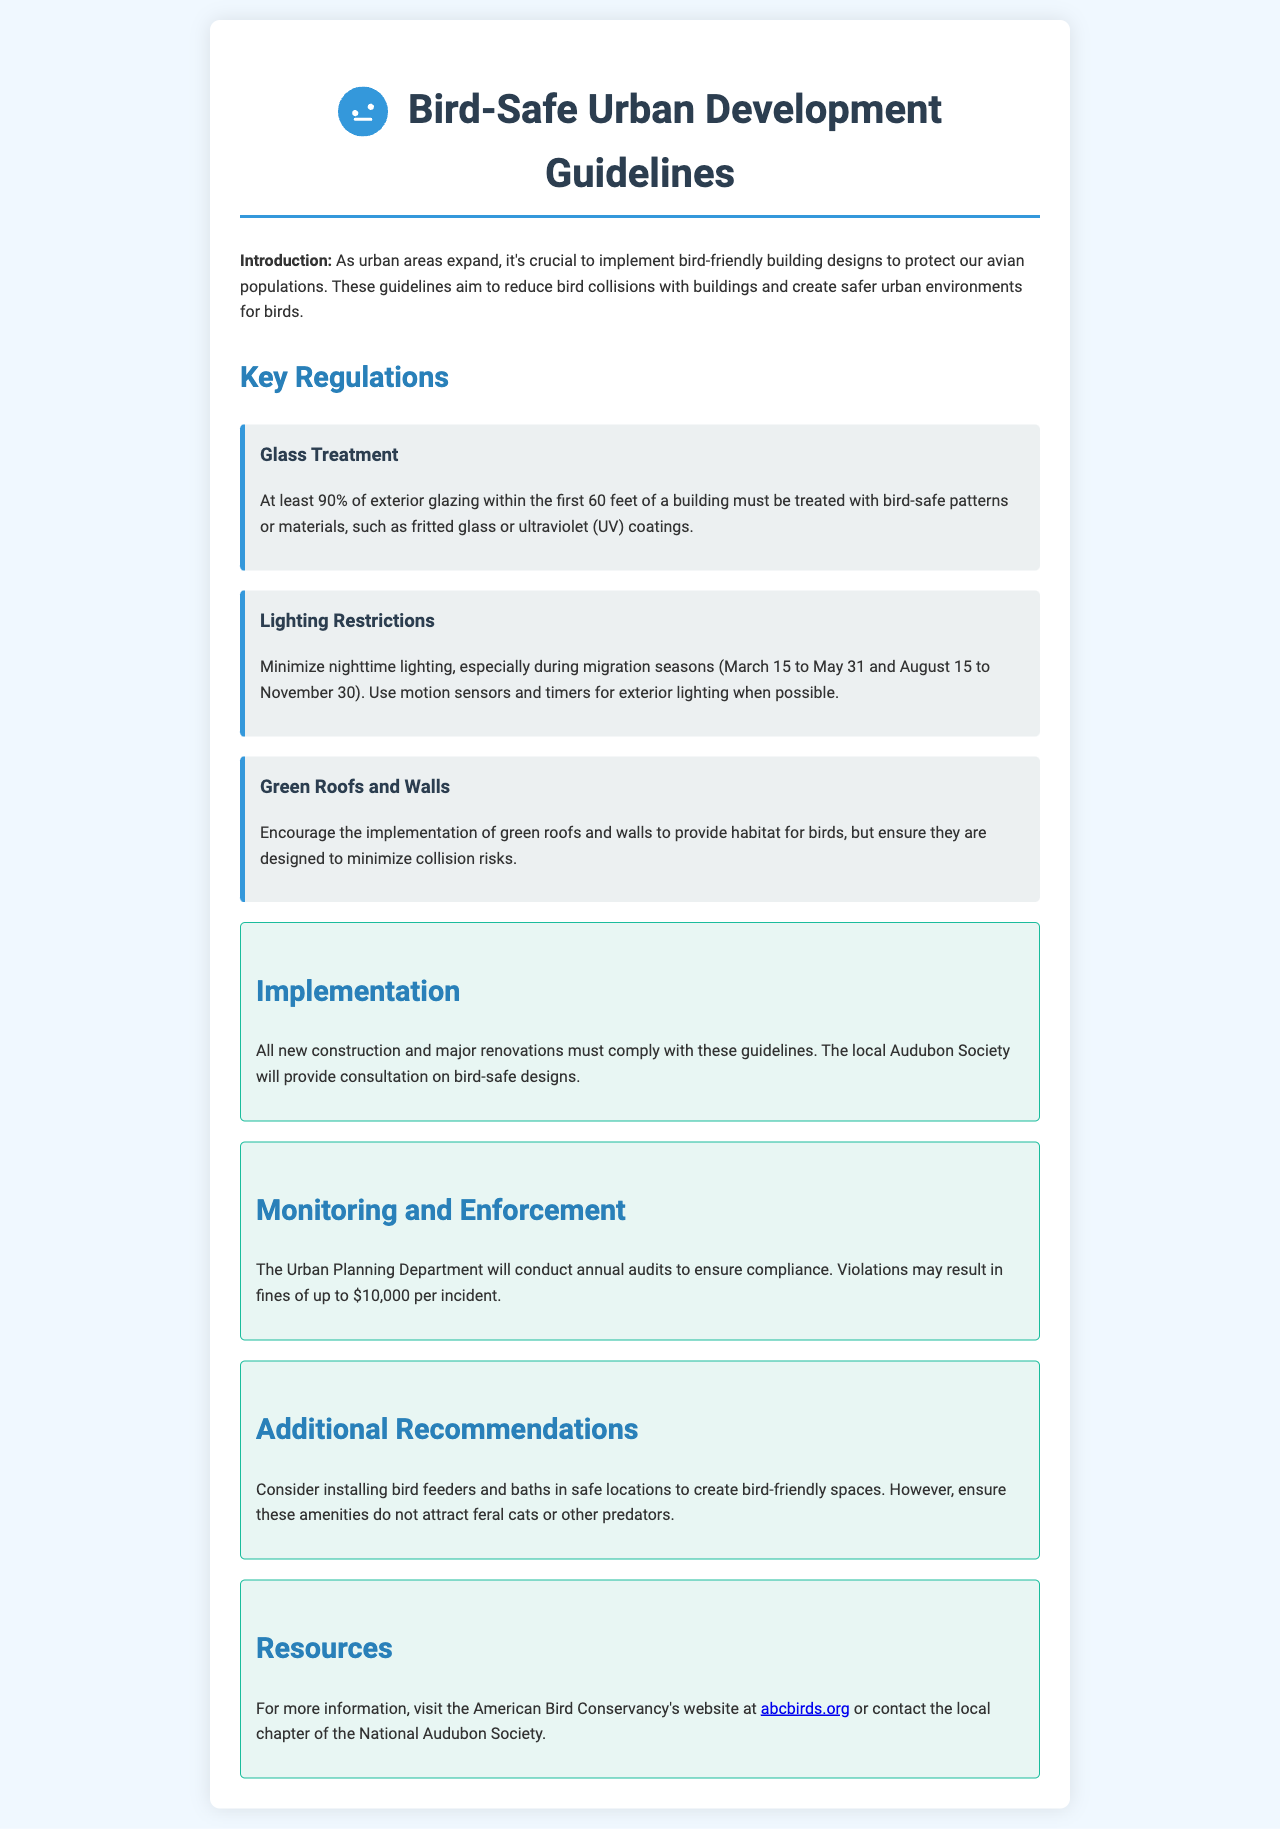what percentage of exterior glazing must be bird-safe treated? The document states that at least 90% of exterior glazing within the first 60 feet must be treated with bird-safe patterns or materials.
Answer: 90% what is the fine for violations of the bird-safe regulations? The document mentions that violations may result in fines of up to $10,000 per incident.
Answer: $10,000 what months are considered migration seasons for lighting restrictions? The document specifies the migration seasons as March 15 to May 31 and August 15 to November 30.
Answer: March 15 to May 31 and August 15 to November 30 who will provide consultation on bird-safe designs? The local Audubon Society is mentioned as the consultant for bird-safe designs.
Answer: local Audubon Society what amenities are recommended to create bird-friendly spaces? The document suggests installing bird feeders and baths in safe locations.
Answer: bird feeders and baths what is the primary goal of the Bird-Safe Urban Development Guidelines? The introduction states that the guidelines aim to protect avian populations by reducing bird collisions with buildings.
Answer: protect avian populations how often will the Urban Planning Department conduct audits for compliance? The document indicates that the Urban Planning Department will conduct annual audits.
Answer: annual which organization’s website is suggested for more information? The document recommends visiting the American Bird Conservancy's website for more information.
Answer: American Bird Conservancy's website 